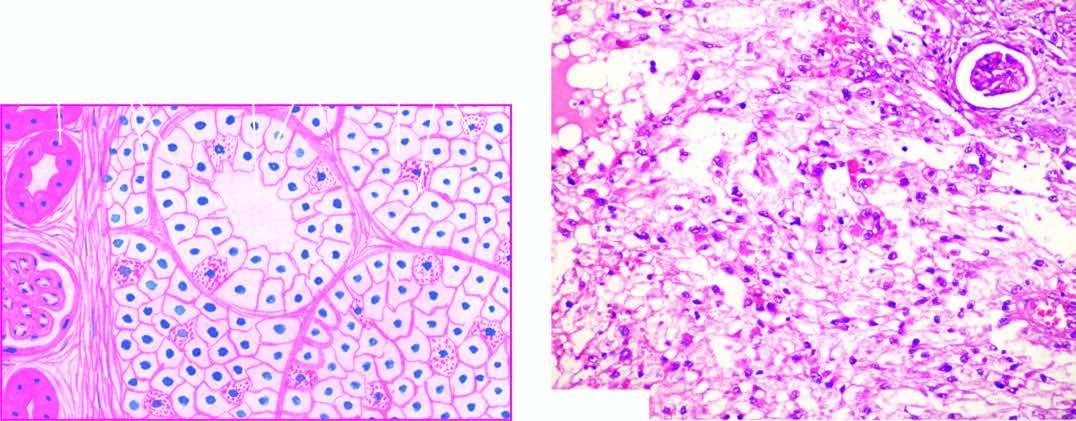what predominate in the tumour while the stroma is composed of fine and delicate fibrous tissue?
Answer the question using a single word or phrase. Clear cells 